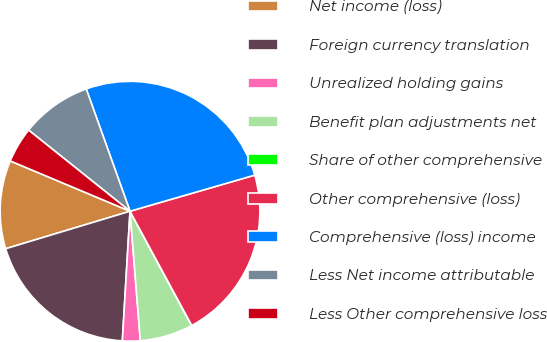<chart> <loc_0><loc_0><loc_500><loc_500><pie_chart><fcel>Net income (loss)<fcel>Foreign currency translation<fcel>Unrealized holding gains<fcel>Benefit plan adjustments net<fcel>Share of other comprehensive<fcel>Other comprehensive (loss)<fcel>Comprehensive (loss) income<fcel>Less Net income attributable<fcel>Less Other comprehensive loss<nl><fcel>10.99%<fcel>19.4%<fcel>2.21%<fcel>6.6%<fcel>0.02%<fcel>21.6%<fcel>25.99%<fcel>8.79%<fcel>4.41%<nl></chart> 